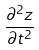Convert formula to latex. <formula><loc_0><loc_0><loc_500><loc_500>\frac { \partial ^ { 2 } z } { \partial t ^ { 2 } }</formula> 